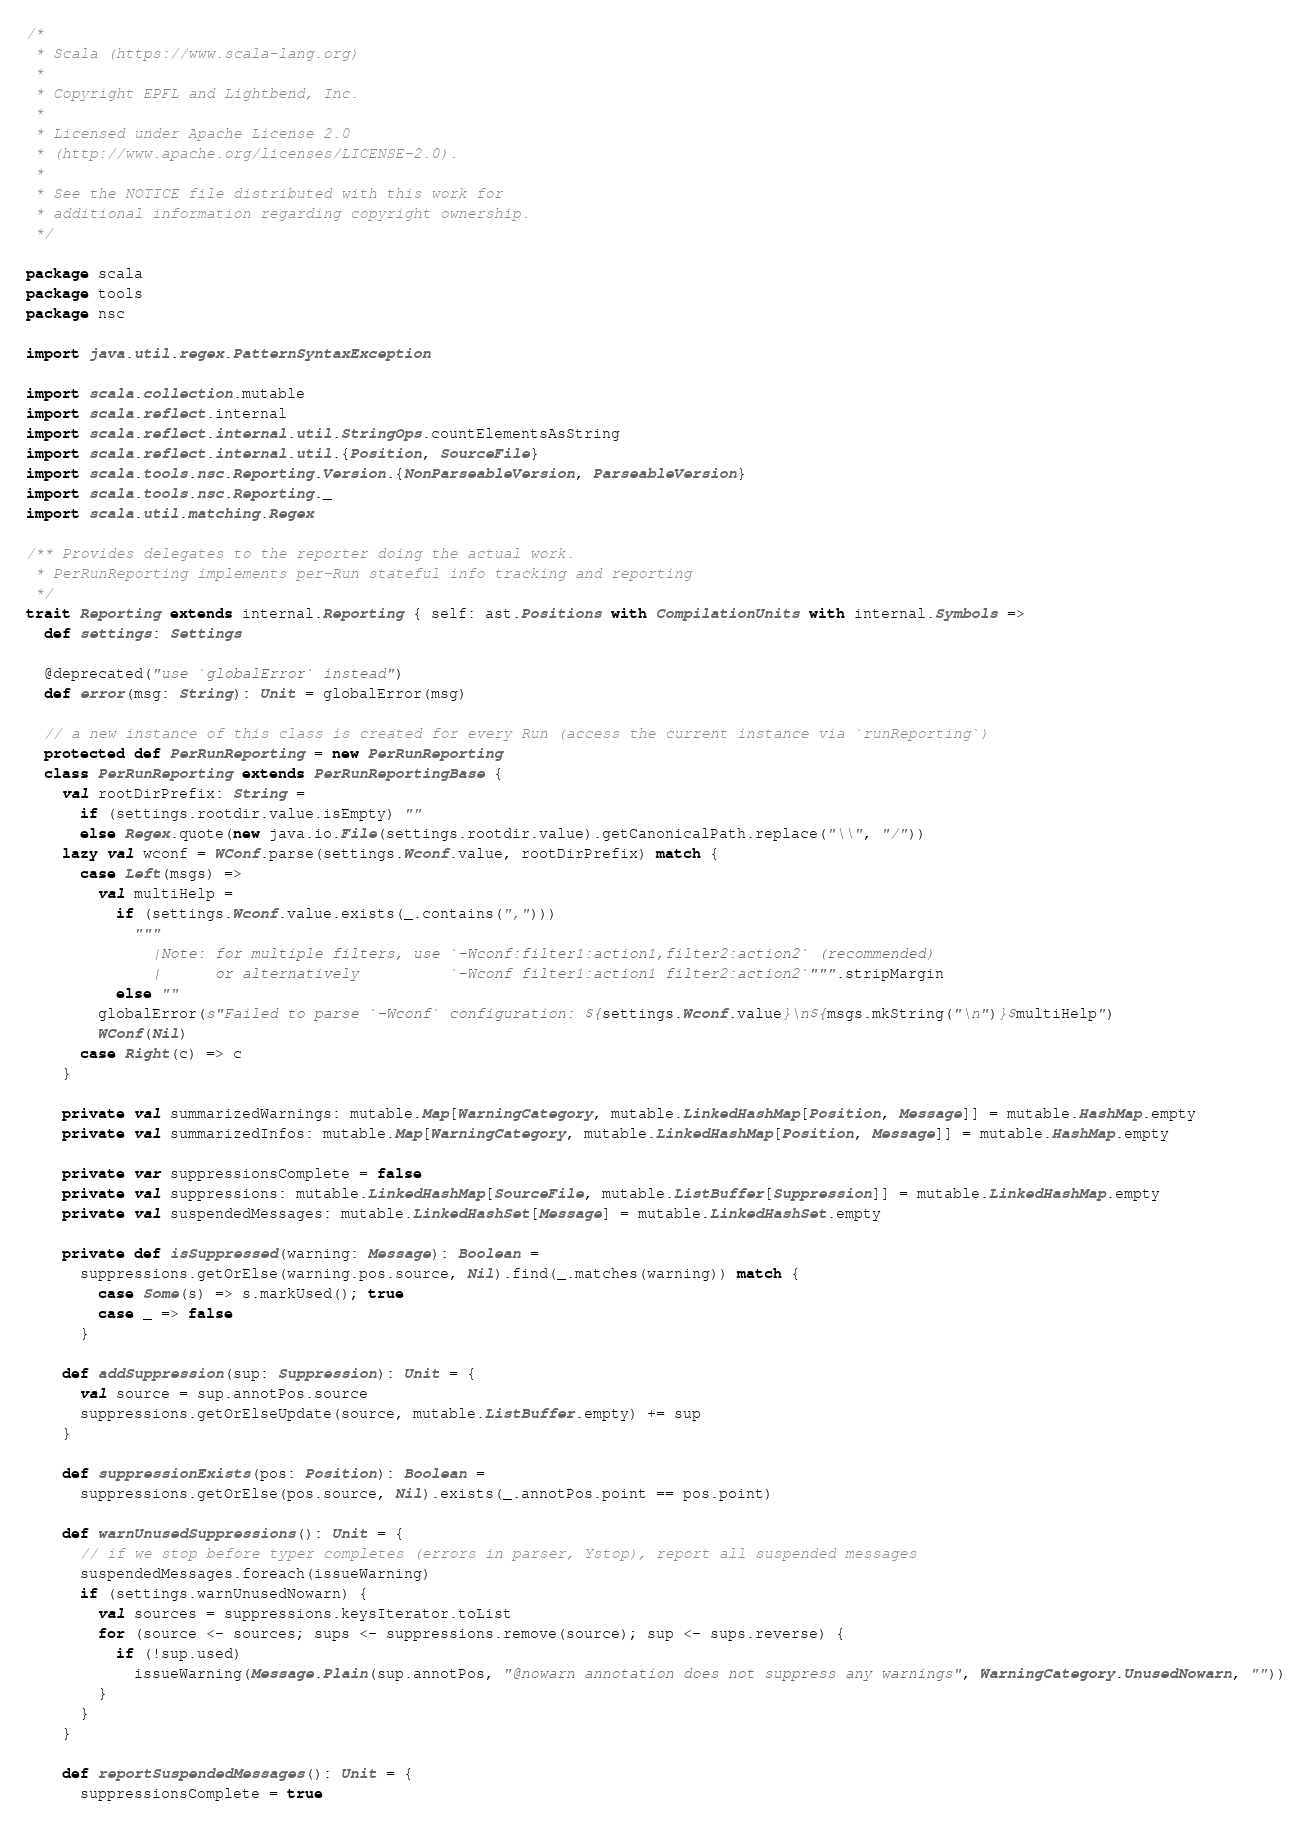<code> <loc_0><loc_0><loc_500><loc_500><_Scala_>/*
 * Scala (https://www.scala-lang.org)
 *
 * Copyright EPFL and Lightbend, Inc.
 *
 * Licensed under Apache License 2.0
 * (http://www.apache.org/licenses/LICENSE-2.0).
 *
 * See the NOTICE file distributed with this work for
 * additional information regarding copyright ownership.
 */

package scala
package tools
package nsc

import java.util.regex.PatternSyntaxException

import scala.collection.mutable
import scala.reflect.internal
import scala.reflect.internal.util.StringOps.countElementsAsString
import scala.reflect.internal.util.{Position, SourceFile}
import scala.tools.nsc.Reporting.Version.{NonParseableVersion, ParseableVersion}
import scala.tools.nsc.Reporting._
import scala.util.matching.Regex

/** Provides delegates to the reporter doing the actual work.
 * PerRunReporting implements per-Run stateful info tracking and reporting
 */
trait Reporting extends internal.Reporting { self: ast.Positions with CompilationUnits with internal.Symbols =>
  def settings: Settings

  @deprecated("use `globalError` instead")
  def error(msg: String): Unit = globalError(msg)

  // a new instance of this class is created for every Run (access the current instance via `runReporting`)
  protected def PerRunReporting = new PerRunReporting
  class PerRunReporting extends PerRunReportingBase {
    val rootDirPrefix: String =
      if (settings.rootdir.value.isEmpty) ""
      else Regex.quote(new java.io.File(settings.rootdir.value).getCanonicalPath.replace("\\", "/"))
    lazy val wconf = WConf.parse(settings.Wconf.value, rootDirPrefix) match {
      case Left(msgs) =>
        val multiHelp =
          if (settings.Wconf.value.exists(_.contains(",")))
            """
              |Note: for multiple filters, use `-Wconf:filter1:action1,filter2:action2` (recommended)
              |      or alternatively          `-Wconf filter1:action1 filter2:action2`""".stripMargin
          else ""
        globalError(s"Failed to parse `-Wconf` configuration: ${settings.Wconf.value}\n${msgs.mkString("\n")}$multiHelp")
        WConf(Nil)
      case Right(c) => c
    }

    private val summarizedWarnings: mutable.Map[WarningCategory, mutable.LinkedHashMap[Position, Message]] = mutable.HashMap.empty
    private val summarizedInfos: mutable.Map[WarningCategory, mutable.LinkedHashMap[Position, Message]] = mutable.HashMap.empty

    private var suppressionsComplete = false
    private val suppressions: mutable.LinkedHashMap[SourceFile, mutable.ListBuffer[Suppression]] = mutable.LinkedHashMap.empty
    private val suspendedMessages: mutable.LinkedHashSet[Message] = mutable.LinkedHashSet.empty

    private def isSuppressed(warning: Message): Boolean =
      suppressions.getOrElse(warning.pos.source, Nil).find(_.matches(warning)) match {
        case Some(s) => s.markUsed(); true
        case _ => false
      }

    def addSuppression(sup: Suppression): Unit = {
      val source = sup.annotPos.source
      suppressions.getOrElseUpdate(source, mutable.ListBuffer.empty) += sup
    }

    def suppressionExists(pos: Position): Boolean =
      suppressions.getOrElse(pos.source, Nil).exists(_.annotPos.point == pos.point)

    def warnUnusedSuppressions(): Unit = {
      // if we stop before typer completes (errors in parser, Ystop), report all suspended messages
      suspendedMessages.foreach(issueWarning)
      if (settings.warnUnusedNowarn) {
        val sources = suppressions.keysIterator.toList
        for (source <- sources; sups <- suppressions.remove(source); sup <- sups.reverse) {
          if (!sup.used)
            issueWarning(Message.Plain(sup.annotPos, "@nowarn annotation does not suppress any warnings", WarningCategory.UnusedNowarn, ""))
        }
      }
    }

    def reportSuspendedMessages(): Unit = {
      suppressionsComplete = true</code> 